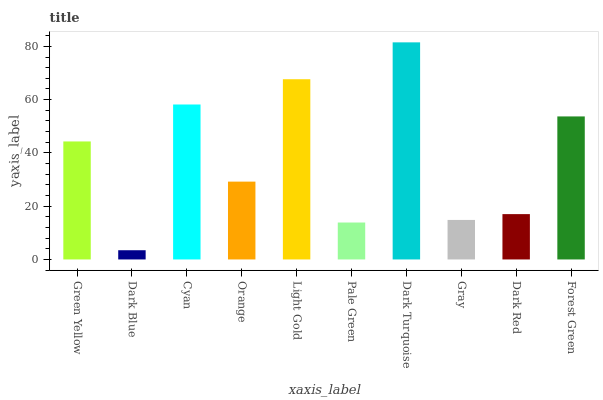Is Dark Blue the minimum?
Answer yes or no. Yes. Is Dark Turquoise the maximum?
Answer yes or no. Yes. Is Cyan the minimum?
Answer yes or no. No. Is Cyan the maximum?
Answer yes or no. No. Is Cyan greater than Dark Blue?
Answer yes or no. Yes. Is Dark Blue less than Cyan?
Answer yes or no. Yes. Is Dark Blue greater than Cyan?
Answer yes or no. No. Is Cyan less than Dark Blue?
Answer yes or no. No. Is Green Yellow the high median?
Answer yes or no. Yes. Is Orange the low median?
Answer yes or no. Yes. Is Dark Blue the high median?
Answer yes or no. No. Is Dark Red the low median?
Answer yes or no. No. 